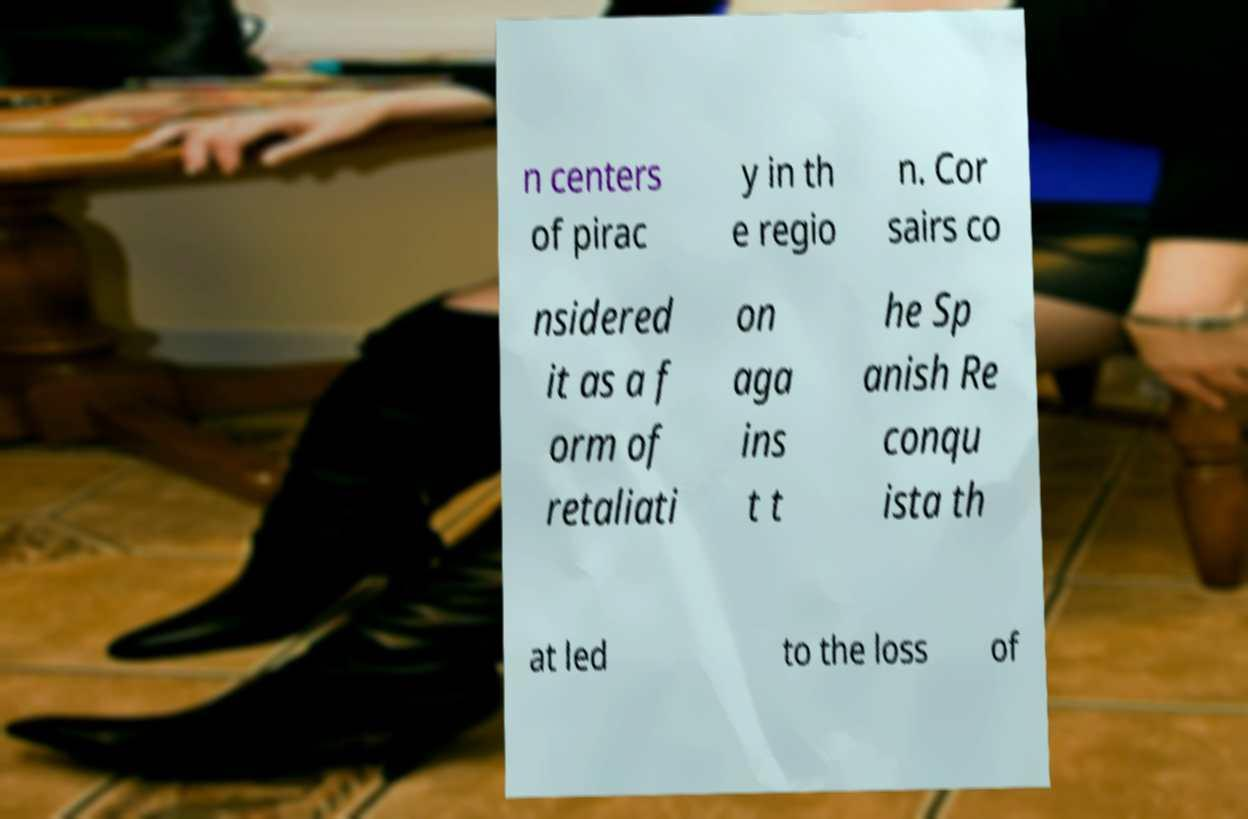Could you assist in decoding the text presented in this image and type it out clearly? n centers of pirac y in th e regio n. Cor sairs co nsidered it as a f orm of retaliati on aga ins t t he Sp anish Re conqu ista th at led to the loss of 